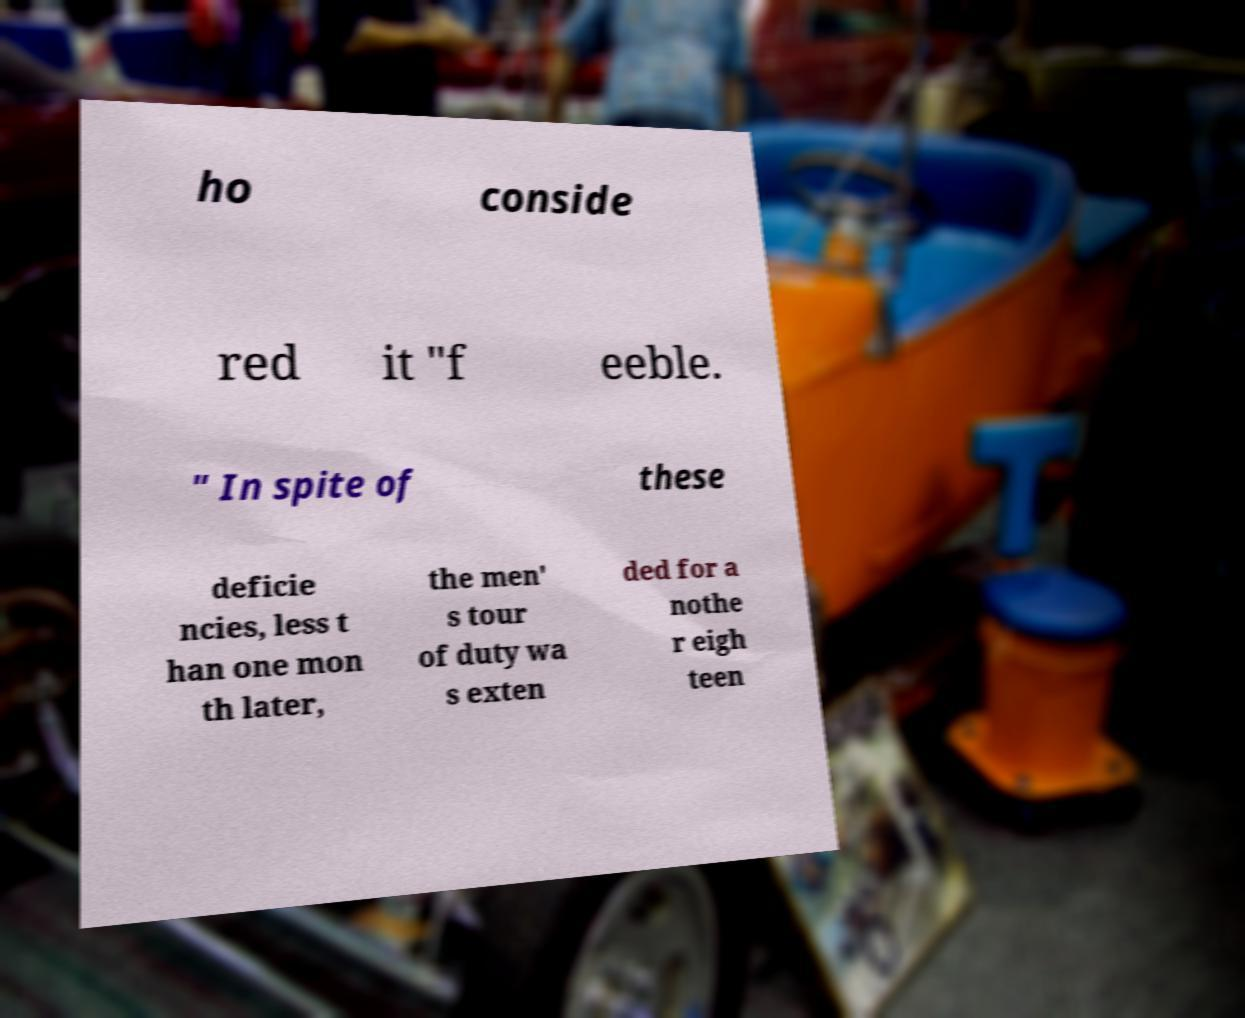Please identify and transcribe the text found in this image. ho conside red it "f eeble. " In spite of these deficie ncies, less t han one mon th later, the men' s tour of duty wa s exten ded for a nothe r eigh teen 